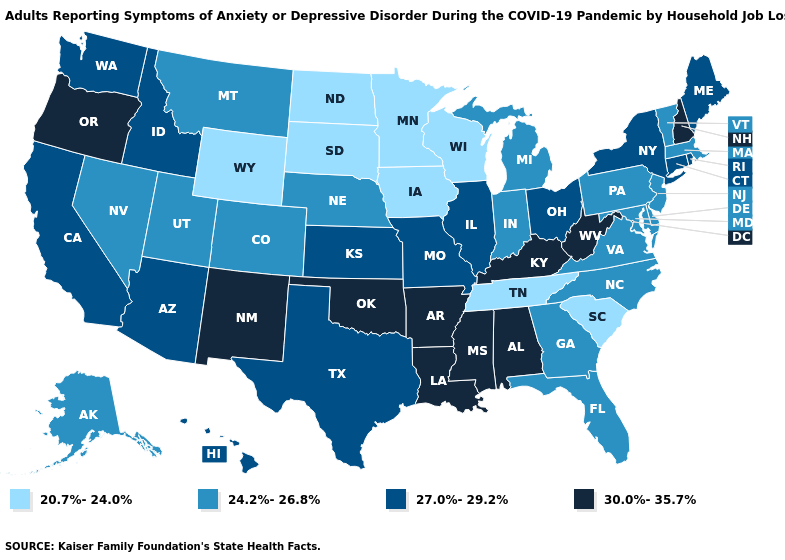Name the states that have a value in the range 27.0%-29.2%?
Answer briefly. Arizona, California, Connecticut, Hawaii, Idaho, Illinois, Kansas, Maine, Missouri, New York, Ohio, Rhode Island, Texas, Washington. What is the lowest value in the USA?
Answer briefly. 20.7%-24.0%. What is the highest value in the USA?
Keep it brief. 30.0%-35.7%. Which states hav the highest value in the MidWest?
Keep it brief. Illinois, Kansas, Missouri, Ohio. Does Kansas have the highest value in the MidWest?
Answer briefly. Yes. Name the states that have a value in the range 20.7%-24.0%?
Keep it brief. Iowa, Minnesota, North Dakota, South Carolina, South Dakota, Tennessee, Wisconsin, Wyoming. What is the value of Illinois?
Answer briefly. 27.0%-29.2%. Among the states that border Kentucky , which have the highest value?
Give a very brief answer. West Virginia. What is the highest value in the West ?
Concise answer only. 30.0%-35.7%. What is the value of California?
Short answer required. 27.0%-29.2%. Does Washington have the lowest value in the USA?
Concise answer only. No. Which states have the lowest value in the USA?
Give a very brief answer. Iowa, Minnesota, North Dakota, South Carolina, South Dakota, Tennessee, Wisconsin, Wyoming. Among the states that border Montana , which have the highest value?
Be succinct. Idaho. Does New Hampshire have the same value as South Carolina?
Give a very brief answer. No. Name the states that have a value in the range 30.0%-35.7%?
Keep it brief. Alabama, Arkansas, Kentucky, Louisiana, Mississippi, New Hampshire, New Mexico, Oklahoma, Oregon, West Virginia. 